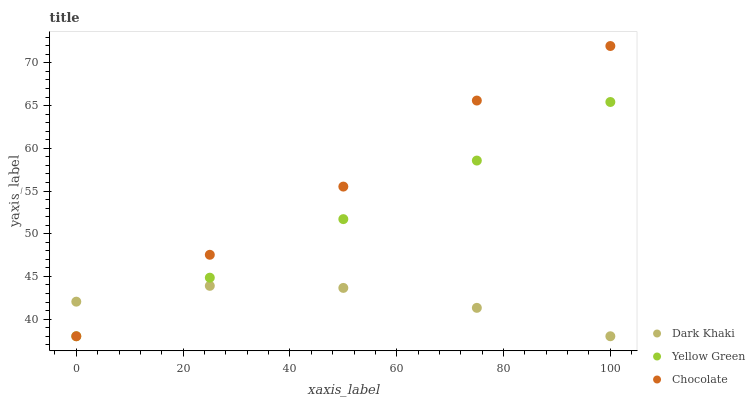Does Dark Khaki have the minimum area under the curve?
Answer yes or no. Yes. Does Chocolate have the maximum area under the curve?
Answer yes or no. Yes. Does Yellow Green have the minimum area under the curve?
Answer yes or no. No. Does Yellow Green have the maximum area under the curve?
Answer yes or no. No. Is Yellow Green the smoothest?
Answer yes or no. Yes. Is Chocolate the roughest?
Answer yes or no. Yes. Is Chocolate the smoothest?
Answer yes or no. No. Is Yellow Green the roughest?
Answer yes or no. No. Does Dark Khaki have the lowest value?
Answer yes or no. Yes. Does Chocolate have the highest value?
Answer yes or no. Yes. Does Yellow Green have the highest value?
Answer yes or no. No. Does Dark Khaki intersect Chocolate?
Answer yes or no. Yes. Is Dark Khaki less than Chocolate?
Answer yes or no. No. Is Dark Khaki greater than Chocolate?
Answer yes or no. No. 